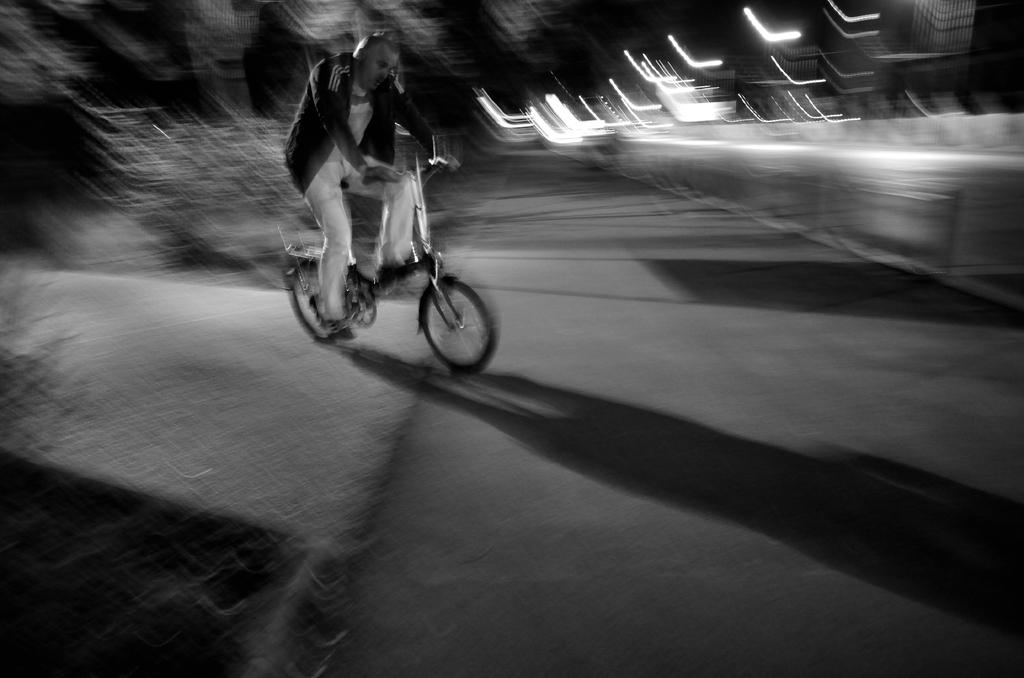Who is present in the image? There is a person in the image. What is the person doing in the image? The person is riding a bicycle. Where is the bicycle located in the image? The bicycle is on the road. What type of tray is being used by the person to balance on the skate in the image? There is no tray or skate present in the image; the person is riding a bicycle on the road. 